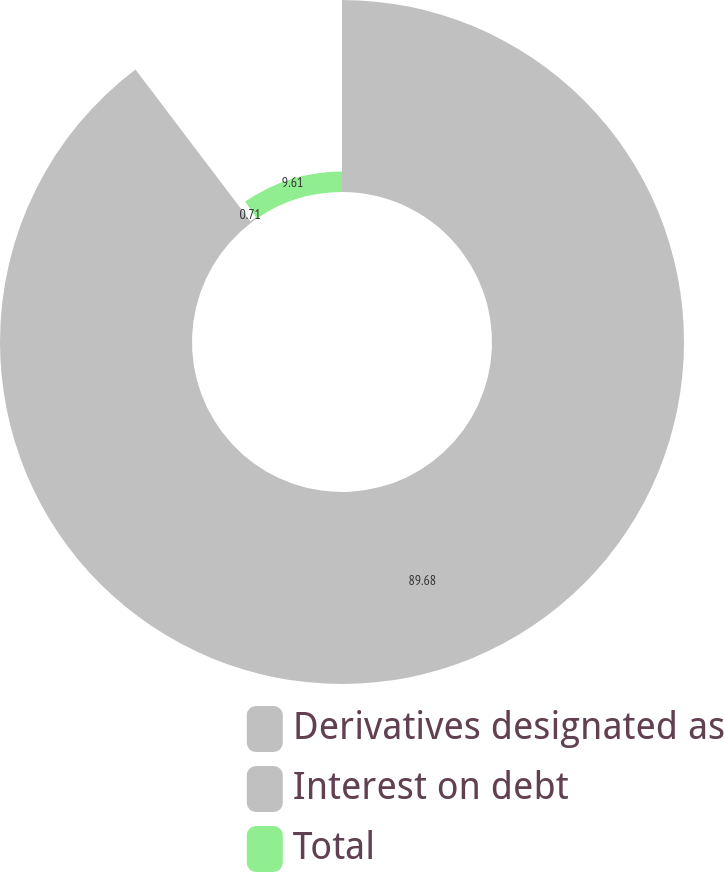<chart> <loc_0><loc_0><loc_500><loc_500><pie_chart><fcel>Derivatives designated as<fcel>Interest on debt<fcel>Total<nl><fcel>89.68%<fcel>0.71%<fcel>9.61%<nl></chart> 